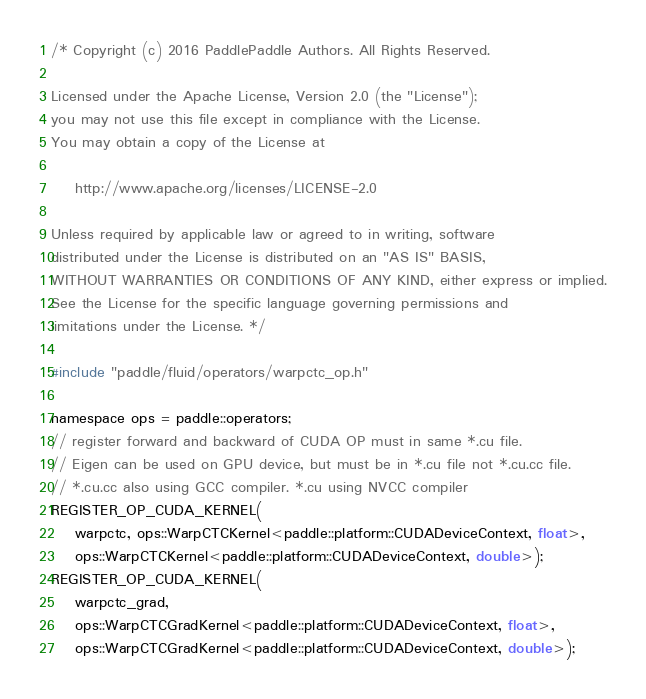Convert code to text. <code><loc_0><loc_0><loc_500><loc_500><_Cuda_>/* Copyright (c) 2016 PaddlePaddle Authors. All Rights Reserved.

Licensed under the Apache License, Version 2.0 (the "License");
you may not use this file except in compliance with the License.
You may obtain a copy of the License at

    http://www.apache.org/licenses/LICENSE-2.0

Unless required by applicable law or agreed to in writing, software
distributed under the License is distributed on an "AS IS" BASIS,
WITHOUT WARRANTIES OR CONDITIONS OF ANY KIND, either express or implied.
See the License for the specific language governing permissions and
limitations under the License. */

#include "paddle/fluid/operators/warpctc_op.h"

namespace ops = paddle::operators;
// register forward and backward of CUDA OP must in same *.cu file.
// Eigen can be used on GPU device, but must be in *.cu file not *.cu.cc file.
// *.cu.cc also using GCC compiler. *.cu using NVCC compiler
REGISTER_OP_CUDA_KERNEL(
    warpctc, ops::WarpCTCKernel<paddle::platform::CUDADeviceContext, float>,
    ops::WarpCTCKernel<paddle::platform::CUDADeviceContext, double>);
REGISTER_OP_CUDA_KERNEL(
    warpctc_grad,
    ops::WarpCTCGradKernel<paddle::platform::CUDADeviceContext, float>,
    ops::WarpCTCGradKernel<paddle::platform::CUDADeviceContext, double>);</code> 